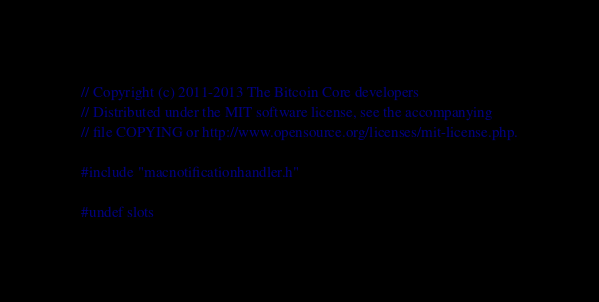Convert code to text. <code><loc_0><loc_0><loc_500><loc_500><_ObjectiveC_>// Copyright (c) 2011-2013 The Bitcoin Core developers
// Distributed under the MIT software license, see the accompanying
// file COPYING or http://www.opensource.org/licenses/mit-license.php.

#include "macnotificationhandler.h"

#undef slots</code> 